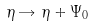<formula> <loc_0><loc_0><loc_500><loc_500>\eta \rightarrow \eta + \Psi _ { 0 }</formula> 